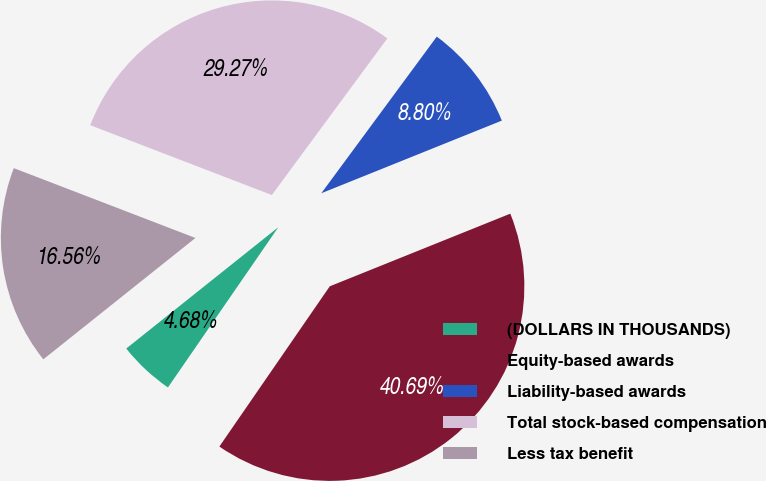Convert chart. <chart><loc_0><loc_0><loc_500><loc_500><pie_chart><fcel>(DOLLARS IN THOUSANDS)<fcel>Equity-based awards<fcel>Liability-based awards<fcel>Total stock-based compensation<fcel>Less tax benefit<nl><fcel>4.68%<fcel>40.69%<fcel>8.8%<fcel>29.27%<fcel>16.56%<nl></chart> 